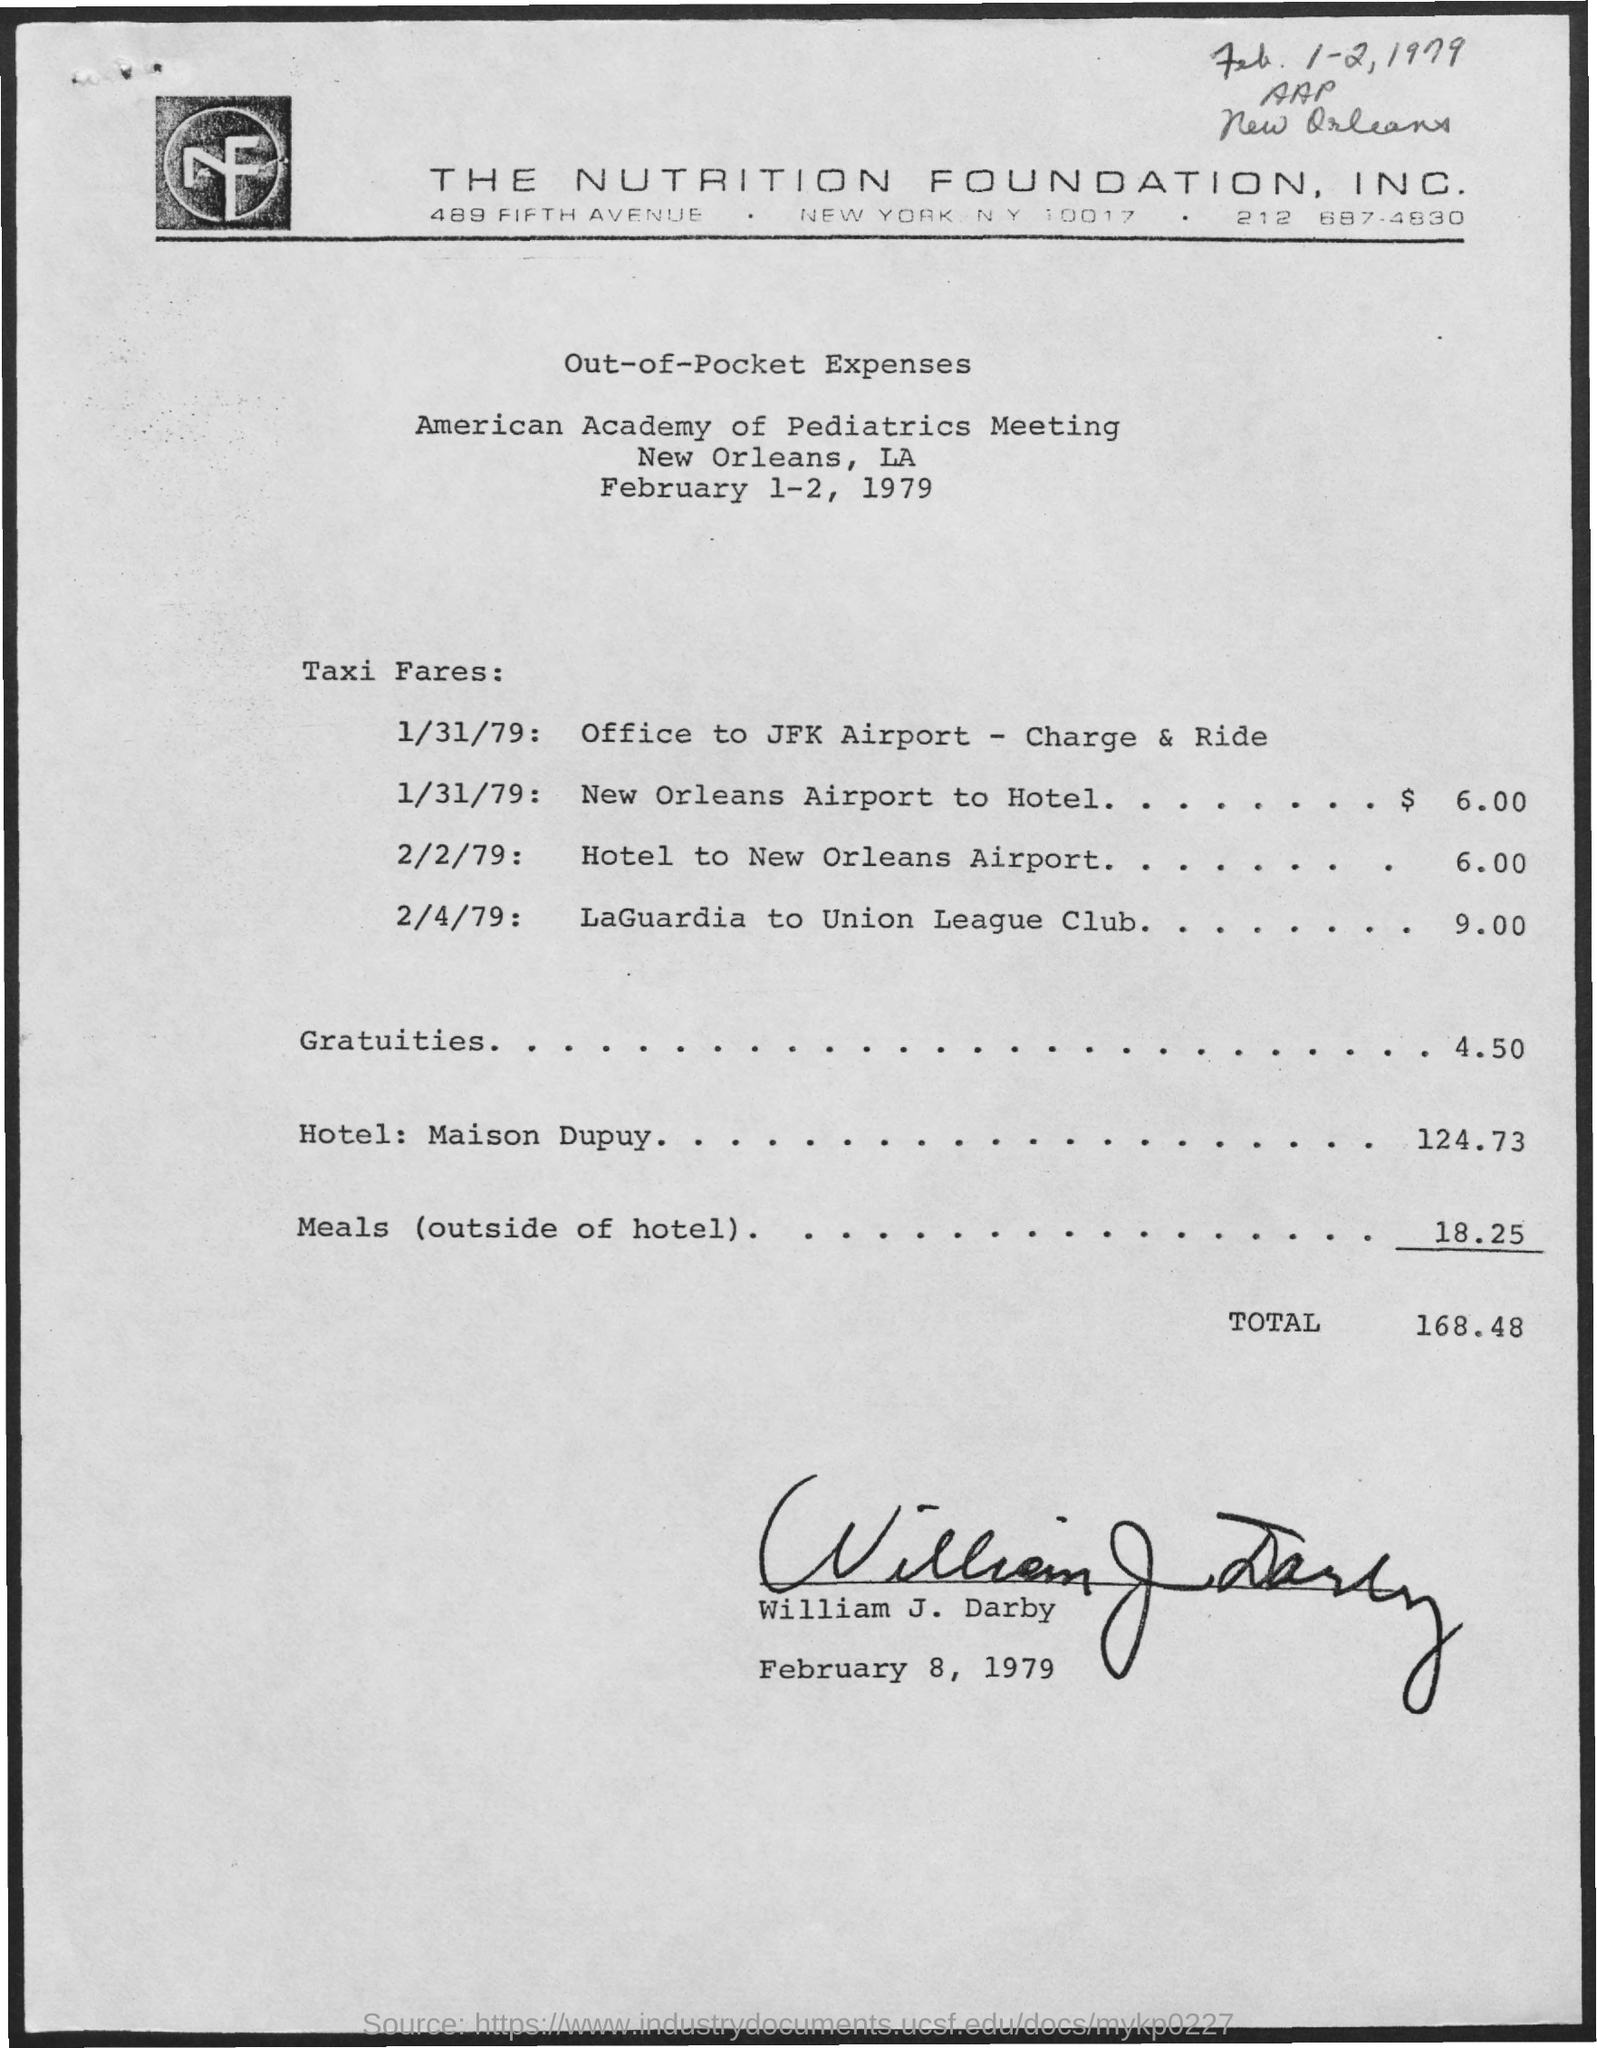Point out several critical features in this image. The person mentioned in the document is named William J. Darby. There is 18.25 meals. On January 31st, 1979, the taxi fare from the New Orleans Airport to the hotel was $6.00. The total is 168.48 dollars. The American Academy of Pediatrics Meeting is taking place. 